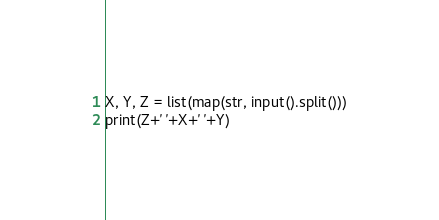Convert code to text. <code><loc_0><loc_0><loc_500><loc_500><_Python_>X, Y, Z = list(map(str, input().split()))
print(Z+' '+X+' '+Y)</code> 